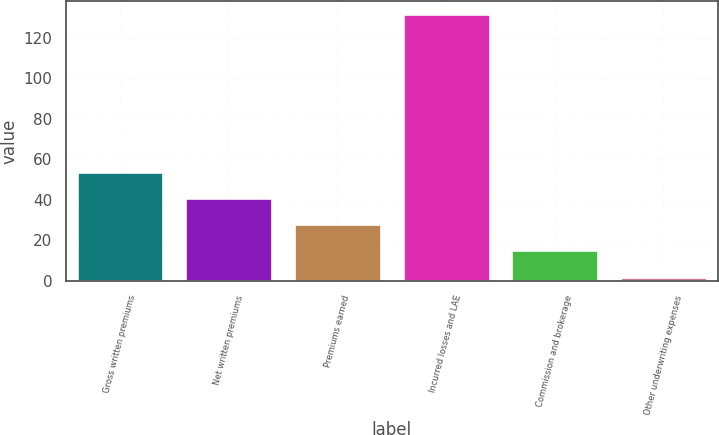<chart> <loc_0><loc_0><loc_500><loc_500><bar_chart><fcel>Gross written premiums<fcel>Net written premiums<fcel>Premiums earned<fcel>Incurred losses and LAE<fcel>Commission and brokerage<fcel>Other underwriting expenses<nl><fcel>53.96<fcel>41.02<fcel>28.08<fcel>131.6<fcel>15.14<fcel>2.2<nl></chart> 